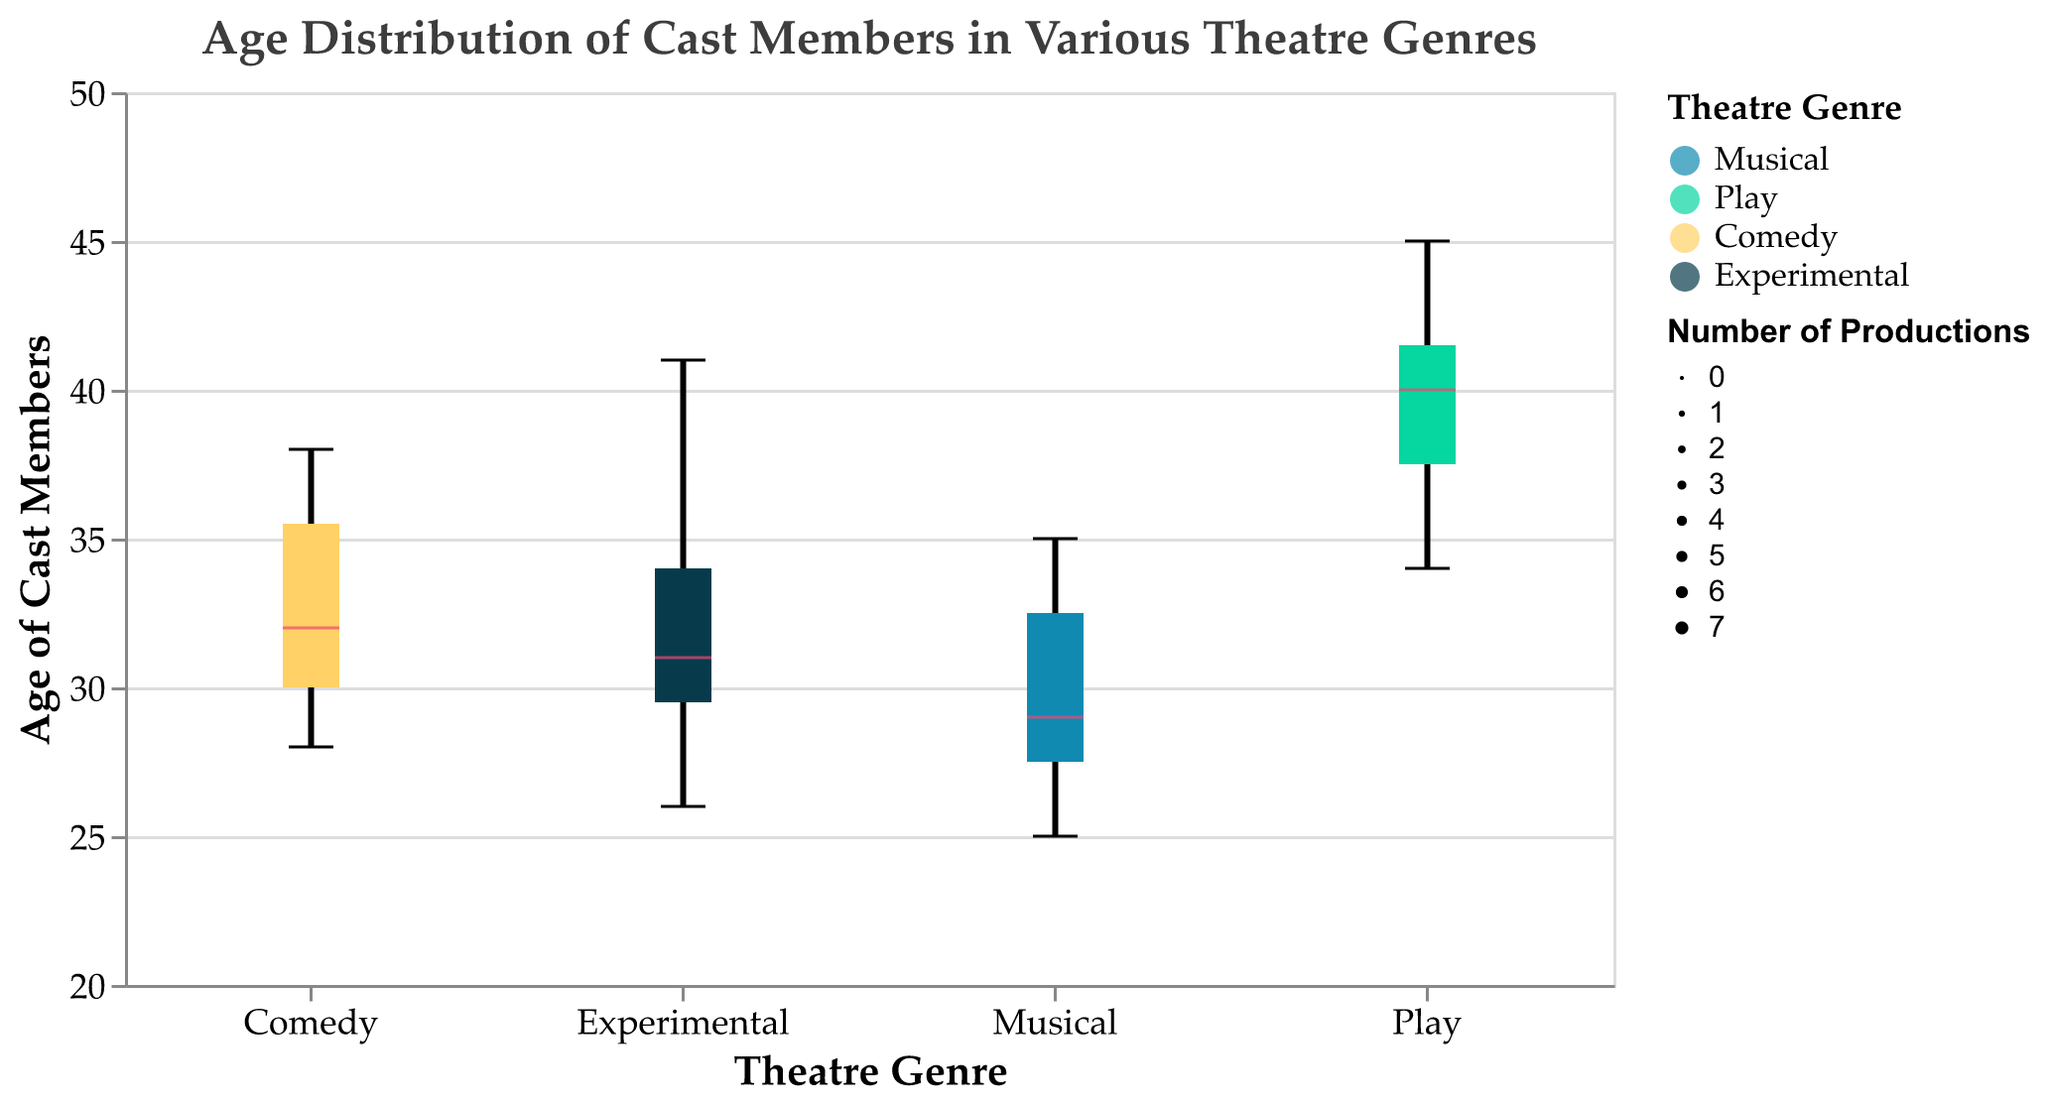What is the median age of cast members in Musicals? To determine the median age of cast members in Musicals, you look at the central value of the data distribution for the Musical genre in the box plot. The median is typically represented by a distinct line within the box of a box plot.
Answer: 29.5 Which theatre genre has the highest median age of cast members? To find the genre with the highest median age, compare the median lines for each genre in the box plot. The one with the highest position on the Y-axis has the highest median age.
Answer: Play Approximately how many cast members are there in the Experimental genre? The width of each box plot corresponds to the number of cast members, with wider boxes indicating more members. The width is also labeled explicitly in the legend or directly on the figure.
Answer: 7 What is the age range of cast members in Comedy? The age range is determined by the minimum and maximum whiskers in the box plot for Comedy. Locate the top and bottom whiskers to find these values.
Answer: 28 to 38 Which theatre genre has the smallest age range among its cast members? By looking at the length of the whiskers for each genre in the box plot, you can identify which genre has the smallest range. The one with the shortest whiskers has the smallest age range.
Answer: Musical Which city has the most diverse cast age distribution within the Musical genre? To assess diversity in age distribution, observe the spread of the box plot for Musicals within each city. The city with the widest box represents the most diverse age range.
Answer: New York How does the median age of Experimental genre compare to Comedy? To compare medians, locate the median line for both Experimental and Comedy genres in the box plot. Note their positions relative to one another.
Answer: Experimental has a higher median than Comedy Identify the age of the oldest cast member in Plays. To find the age of the oldest cast member in Plays, look at the top whisker of the box plot for the Play genre, which represents the maximum age value.
Answer: 45 Among the genres, which has the most consistent age of cast members? Consistency can be inferred from the smallest interquartile range (IQR), represented by the width of the box. The genre with the narrowest box has the most consistent ages.
Answer: Comedy Is the age distribution of cast members in Musicals skewed towards younger or older ages? Determine the skewness by examining the position of the median line within the box. If the median is closer to the bottom, it’s skewed towards younger ages, and if closer to the top, towards older.
Answer: Slightly skewed towards younger ages 